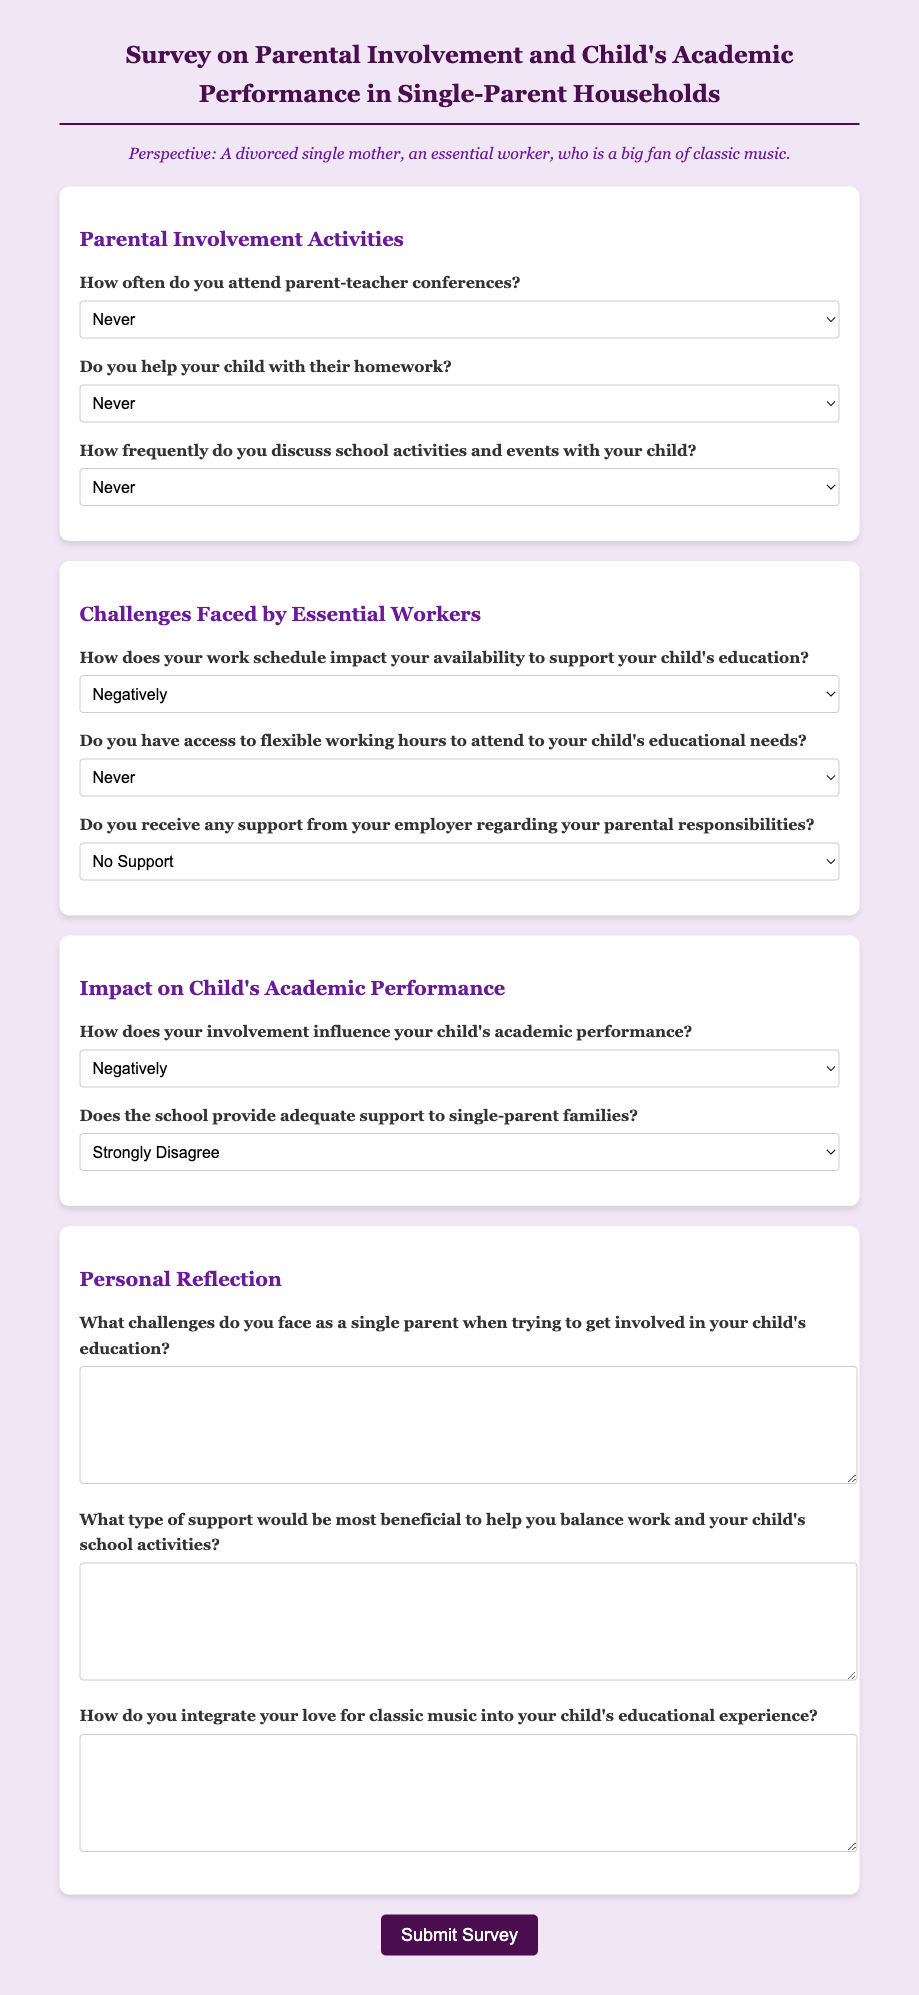How often do you attend parent-teacher conferences? This question appears in the "Parental Involvement Activities" section of the survey, asking about the frequency of attending conferences.
Answer: Select one option from: Never, Rarely, Sometimes, Often, Always What is the maximum number of options available for the question about homework help? The number of options for the homework help question indicates the frequency of assistance given to children.
Answer: Five options How does your work schedule impact your availability to support your child's education? This question probes the relationship between work scheduling and educational support, categorized in the challenges faced section.
Answer: Select one option from: Negatively, Somewhat Negatively, Neutral, Somewhat Positively, Positively What type of support would be most beneficial for balancing work and schooling? This question requires respondents to consider their needs in the context of managing work and educational responsibilities and is positioned in the personal reflection section.
Answer: Open-ended response in a textarea Does the school provide adequate support to single-parent families? This question seeks an opinion on the school's support for single parents, found in the impact section of the survey.
Answer: Select one option from: Strongly Disagree, Disagree, Neutral, Agree, Strongly Agree 